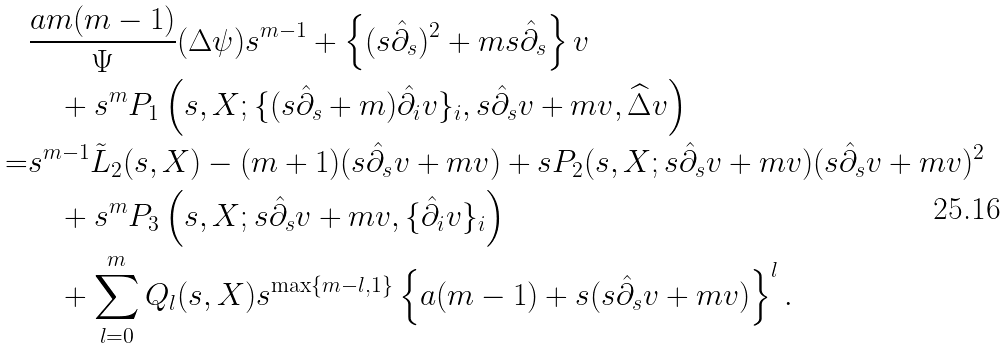Convert formula to latex. <formula><loc_0><loc_0><loc_500><loc_500>& \frac { a m ( m - 1 ) } { \Psi } ( \Delta \psi ) s ^ { m - 1 } + \left \{ ( s { \hat { \partial } } _ { s } ) ^ { 2 } + m s { \hat { \partial } } _ { s } \right \} v \\ & \quad + s ^ { m } P _ { 1 } \left ( s , X ; \{ ( s { \hat { \partial } } _ { s } + m ) { \hat { \partial } } _ { i } v \} _ { i } , s { \hat { \partial } } _ { s } v + m v , \widehat { \Delta } v \right ) \\ = & s ^ { m - 1 } \tilde { L } _ { 2 } ( s , X ) - ( m + 1 ) ( s { \hat { \partial } } _ { s } v + m v ) + s P _ { 2 } ( s , X ; s { \hat { \partial } } _ { s } v + m v ) ( s { \hat { \partial } } _ { s } v + m v ) ^ { 2 } \\ & \quad + s ^ { m } P _ { 3 } \left ( s , X ; s { \hat { \partial } } _ { s } v + m v , \{ { \hat { \partial } } _ { i } v \} _ { i } \right ) \\ & \quad + \sum _ { l = 0 } ^ { m } Q _ { l } ( s , X ) s ^ { \max \{ m - l , 1 \} } \left \{ a ( m - 1 ) + s ( s { \hat { \partial } } _ { s } v + m v ) \right \} ^ { l } .</formula> 